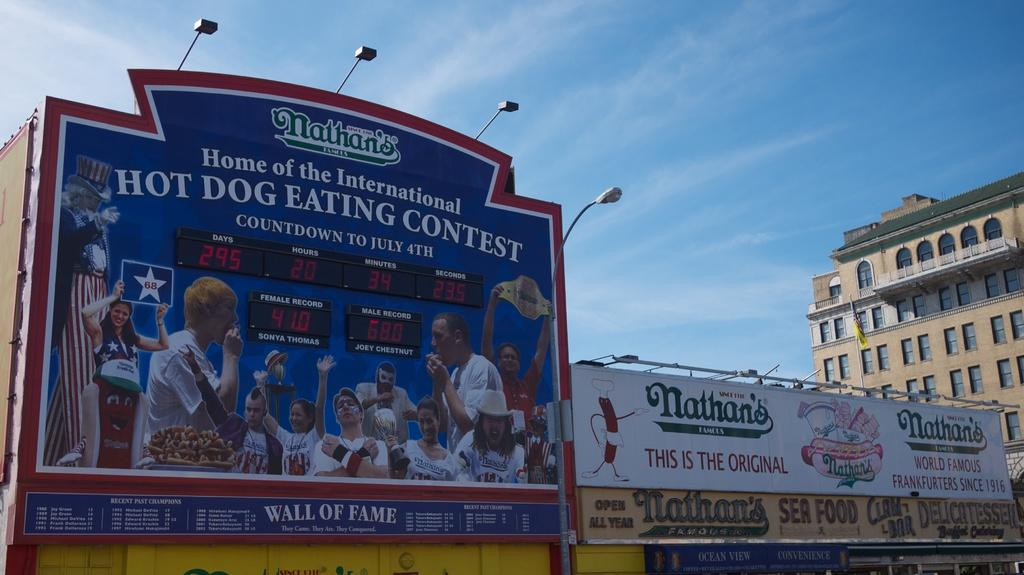<image>
Present a compact description of the photo's key features. A billboard that is advertising a Hot Dog Eating Contest that is blue with white letters and has people eating on it. 